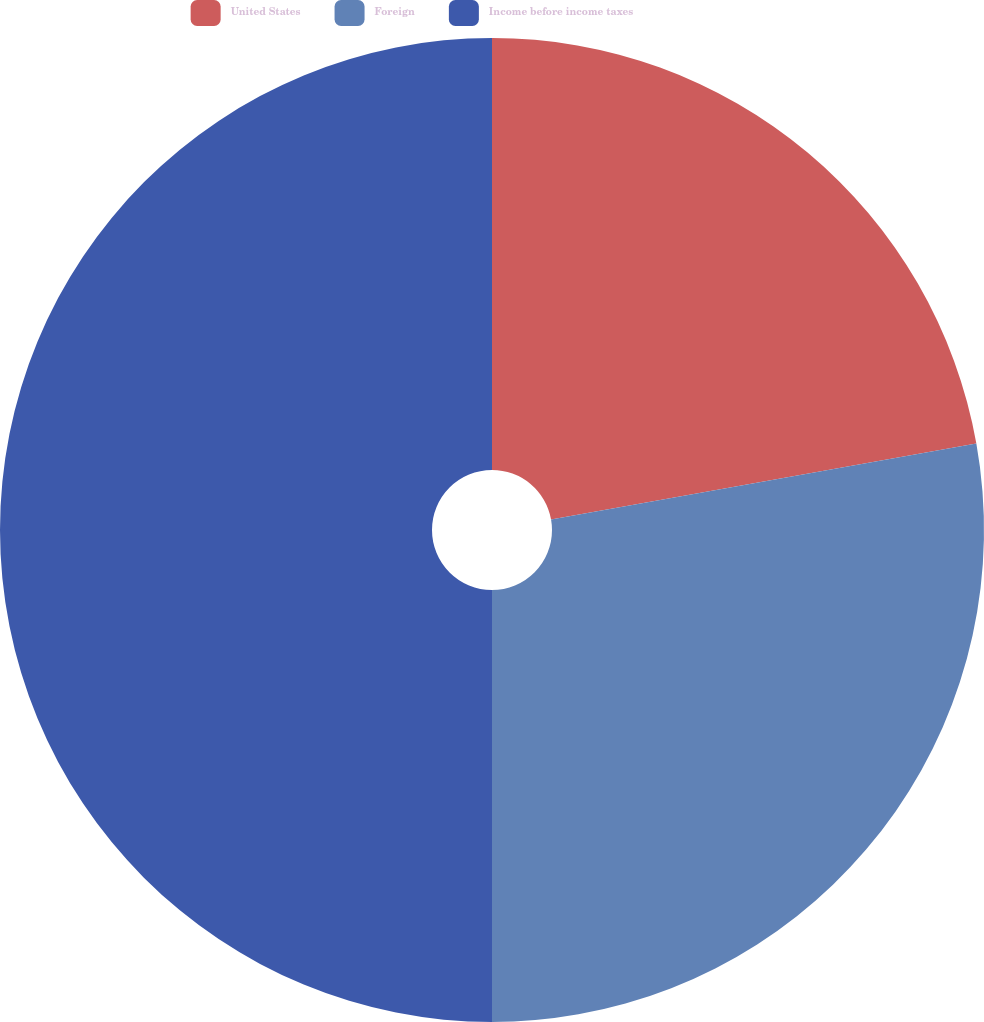Convert chart. <chart><loc_0><loc_0><loc_500><loc_500><pie_chart><fcel>United States<fcel>Foreign<fcel>Income before income taxes<nl><fcel>22.19%<fcel>27.81%<fcel>50.0%<nl></chart> 